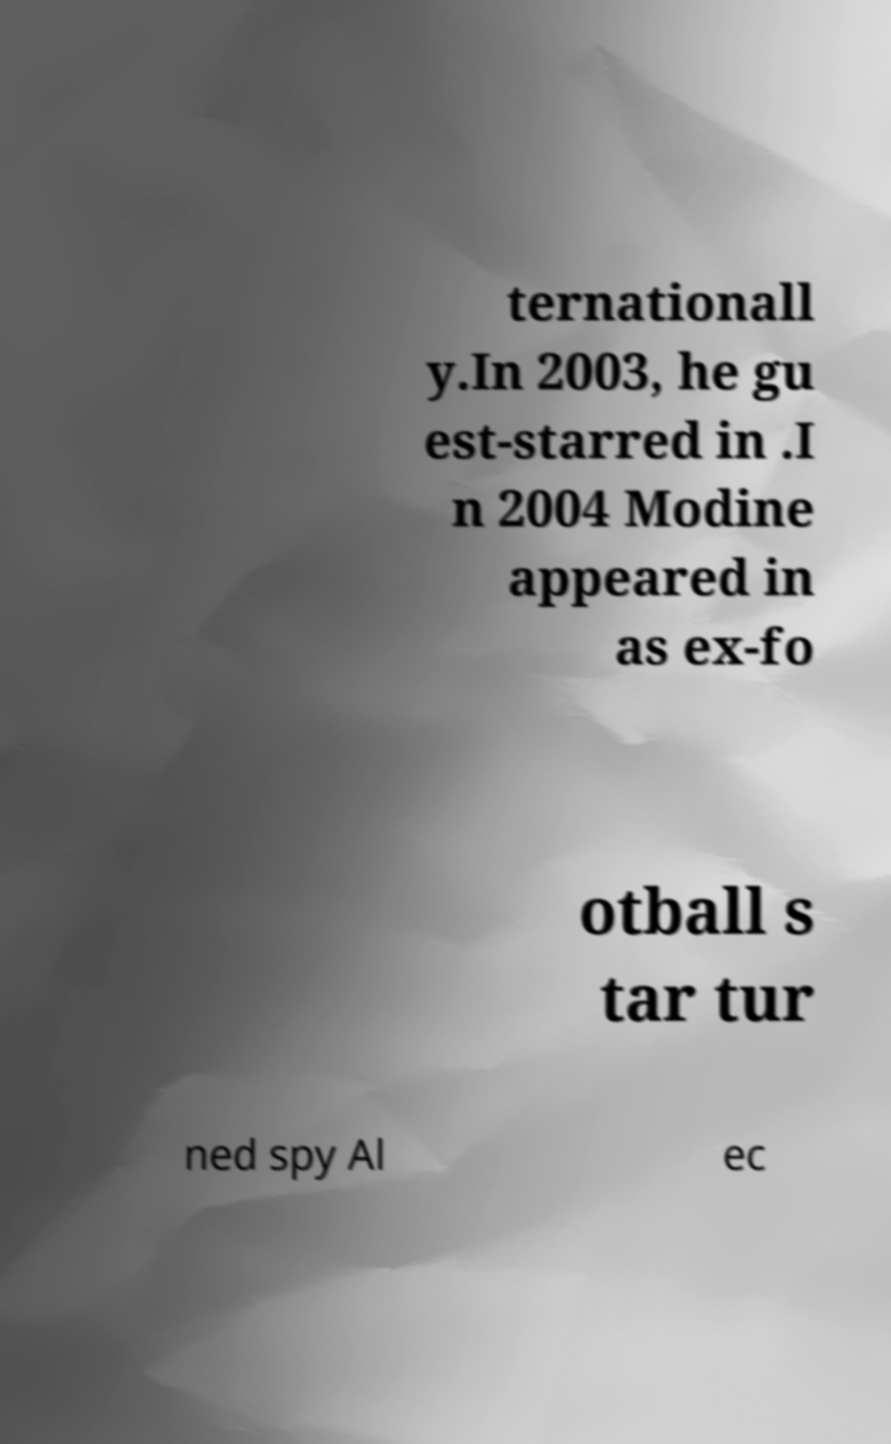Please identify and transcribe the text found in this image. ternationall y.In 2003, he gu est-starred in .I n 2004 Modine appeared in as ex-fo otball s tar tur ned spy Al ec 